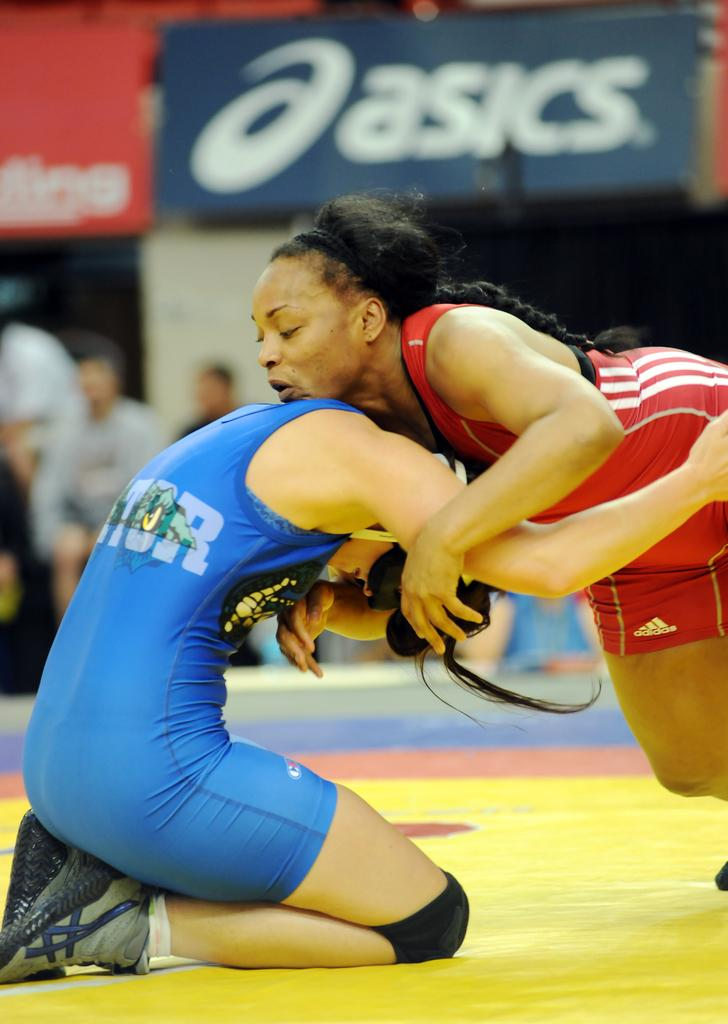<image>
Provide a brief description of the given image. Two female wrestlers are grappled with the Asics logo in the background. 